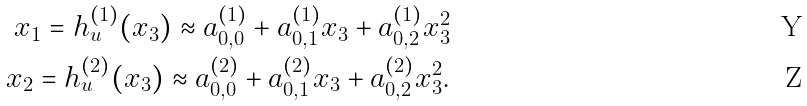Convert formula to latex. <formula><loc_0><loc_0><loc_500><loc_500>x _ { 1 } = h ^ { ( 1 ) } _ { u } ( x _ { 3 } ) \approx a ^ { ( 1 ) } _ { 0 , 0 } + a ^ { ( 1 ) } _ { 0 , 1 } x _ { 3 } + a ^ { ( 1 ) } _ { 0 , 2 } x _ { 3 } ^ { 2 } \\ x _ { 2 } = h ^ { ( 2 ) } _ { u } ( x _ { 3 } ) \approx a ^ { ( 2 ) } _ { 0 , 0 } + a ^ { ( 2 ) } _ { 0 , 1 } x _ { 3 } + a ^ { ( 2 ) } _ { 0 , 2 } x _ { 3 } ^ { 2 } .</formula> 